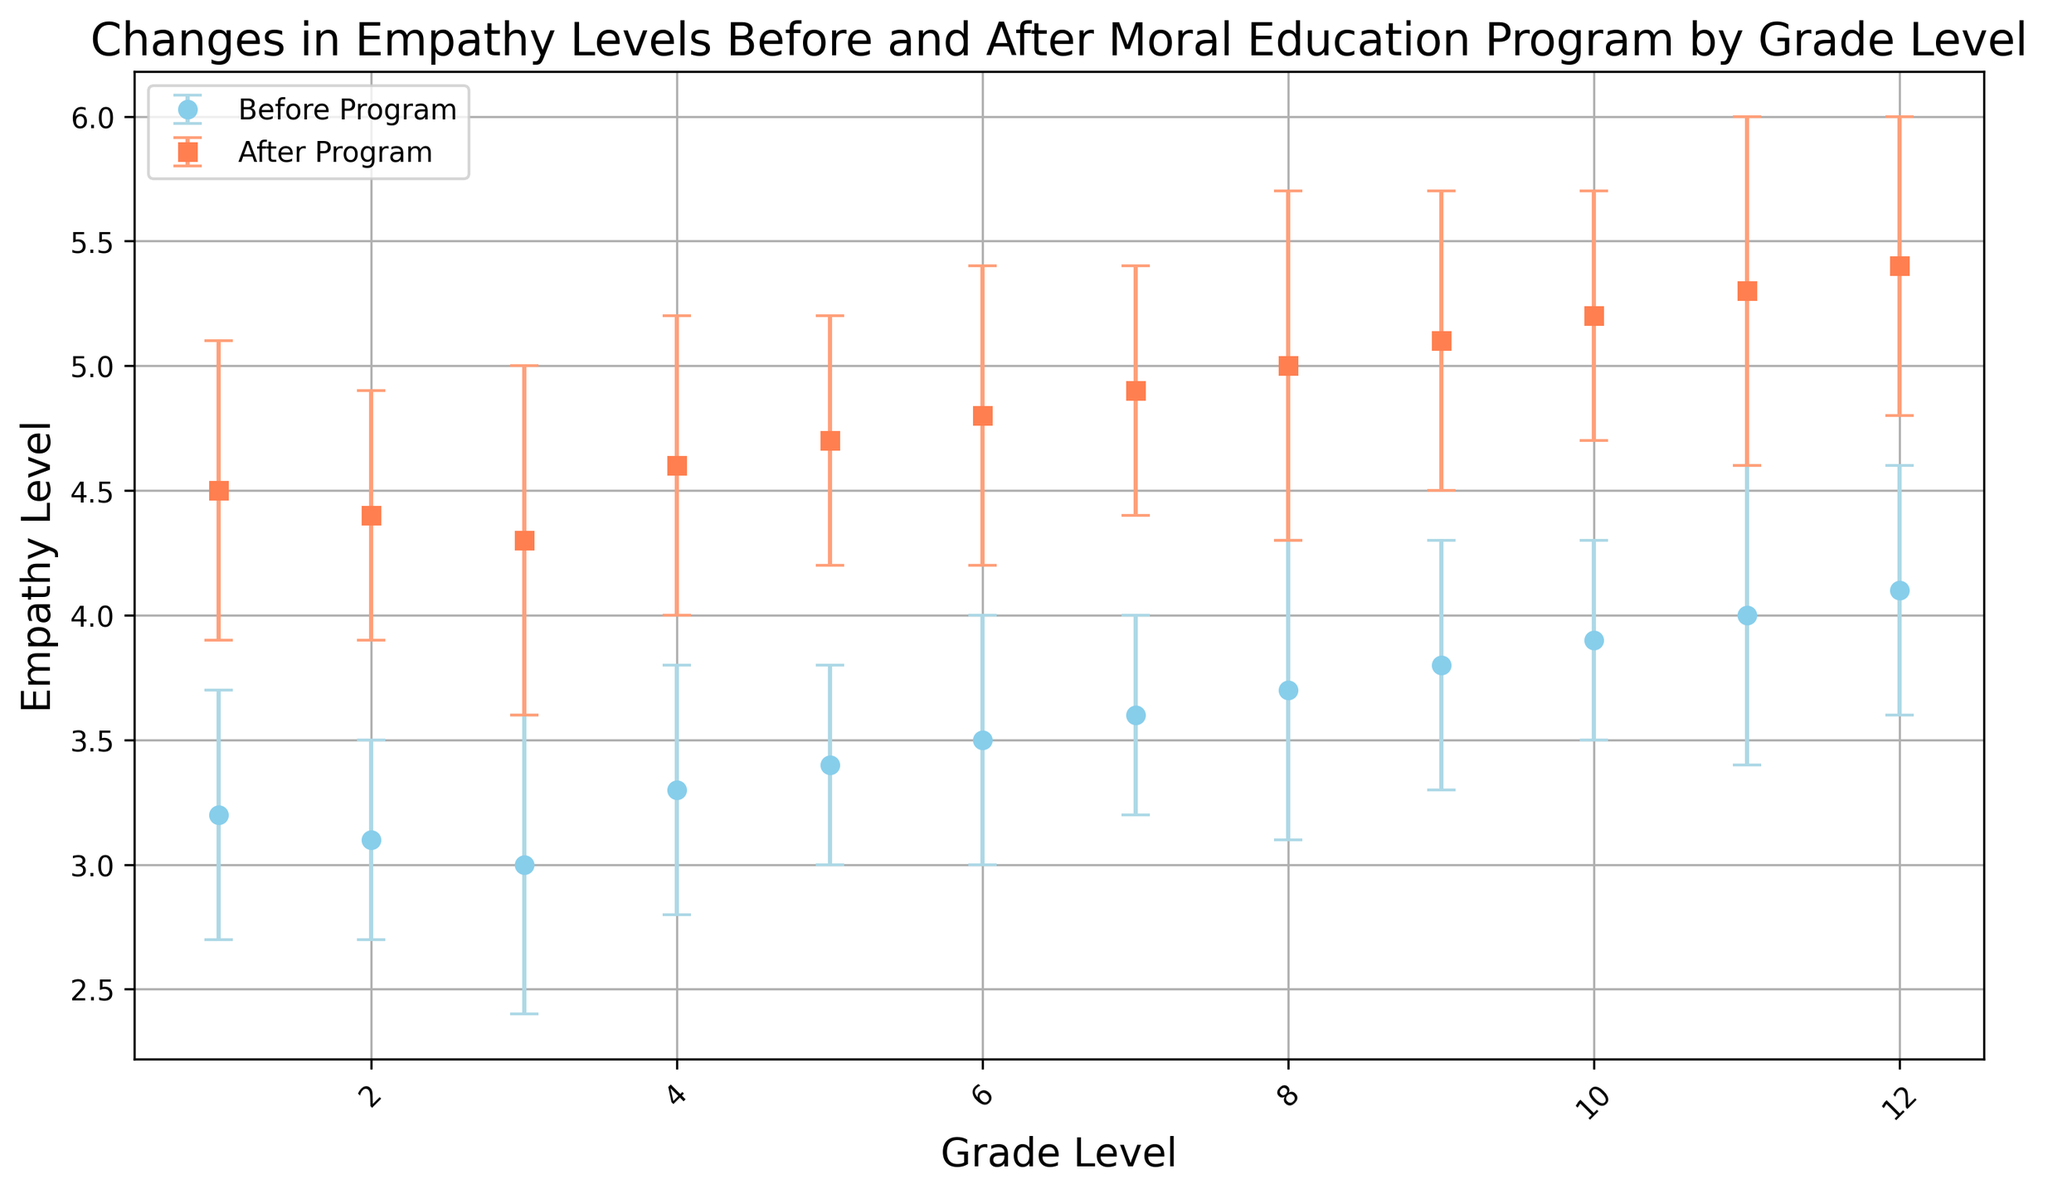What is the general trend in empathy levels from before to after the program? Both the empathy levels before and after the program increase as grade levels increase. The post-program empathy levels are consistently higher than the pre-program empathy levels across all grade levels.
Answer: Increase Which grade level showed the highest increase in empathy levels after the program? To find the highest increase, calculate the difference between after and before for each grade. The highest increase is for grade 12: 5.4 - 4.1 = 1.3.
Answer: Grade 12 Are there any grade levels with overlapping error bars between the before and after measurements? To check for overlapping error bars, we look for overlap in the vertical intervals represented by the error bars. There are no overlapping error bars between the before and after measurements for any grade level.
Answer: No Which grade had the smallest standard deviation in empathy levels after the program? By looking at the error bars for the after program measurements, the smallest standard deviation after the program is for grade 2 and grade 10, both with a standard deviation of 0.5.
Answer: Grade 2, Grade 10 Does the trend in standard deviations before and after the program show a consistent pattern across grades? The standard deviations (error bars) do not show a consistent trend. For example, grades 1, 4, 7, and 11 have higher standard deviations after the program, while other grades have no significant changes or a slight decrease.
Answer: No What is the empathy level for grade 5 students before and after the program? The empathy level for grade 5 students before the program is 3.4, and after the program, it is 4.7.
Answer: 3.4 before, 4.7 after How does the empathy level change for grade 8 students after the program? The empathy level for grade 8 students increased from 3.7 to 5.0, which means it increased by 1.3.
Answer: Increased by 1.3 Which grade levels have an empathy level after the program above 5.0? By examining the plot, the grade levels with empathy level above 5.0 after the program are grades 9, 10, 11, and 12.
Answer: Grades 9, 10, 11, 12 Compare the empathy levels after the program between grade 6 and grade 7. Which is higher? The empathy level after the program for grade 6 is 4.8, and for grade 7 is 4.9. Therefore, the empathy level is higher for grade 7.
Answer: Grade 7 Which grade level had the smallest increase in empathy levels after the program? To find the smallest increase, calculate the difference between after and before for each grade. The smallest increase is for grade 1: 4.5 - 3.2 = 1.3. The increases are the same for every grade.
Answer: All grade levels had the same increase 